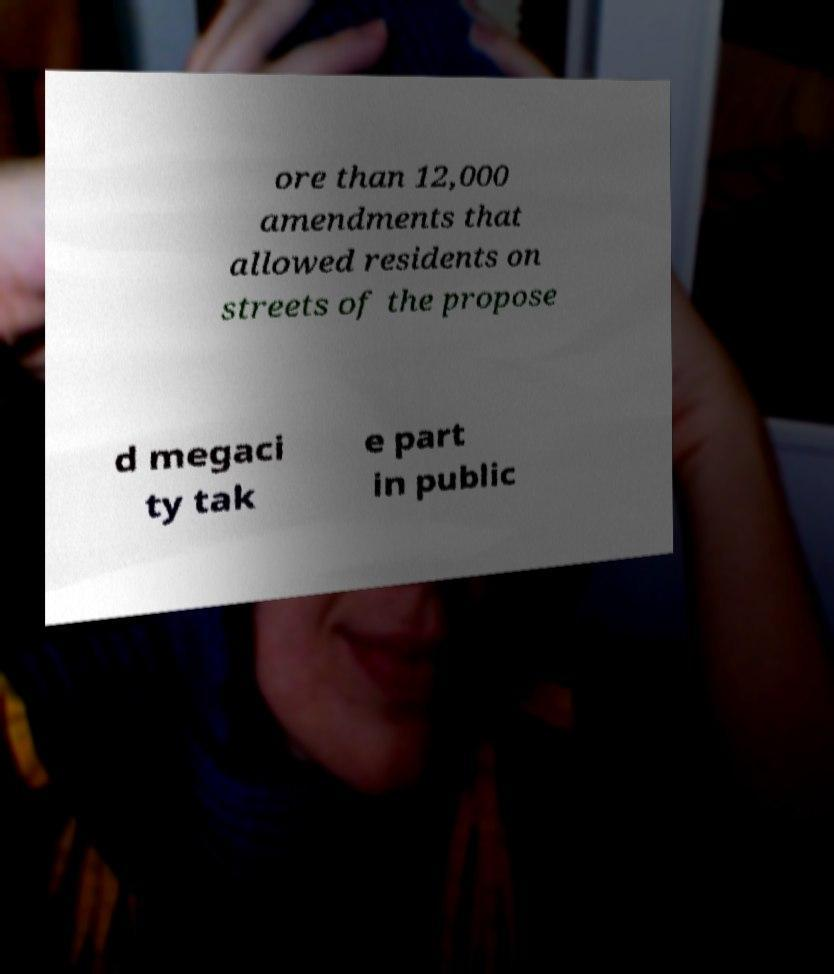For documentation purposes, I need the text within this image transcribed. Could you provide that? ore than 12,000 amendments that allowed residents on streets of the propose d megaci ty tak e part in public 